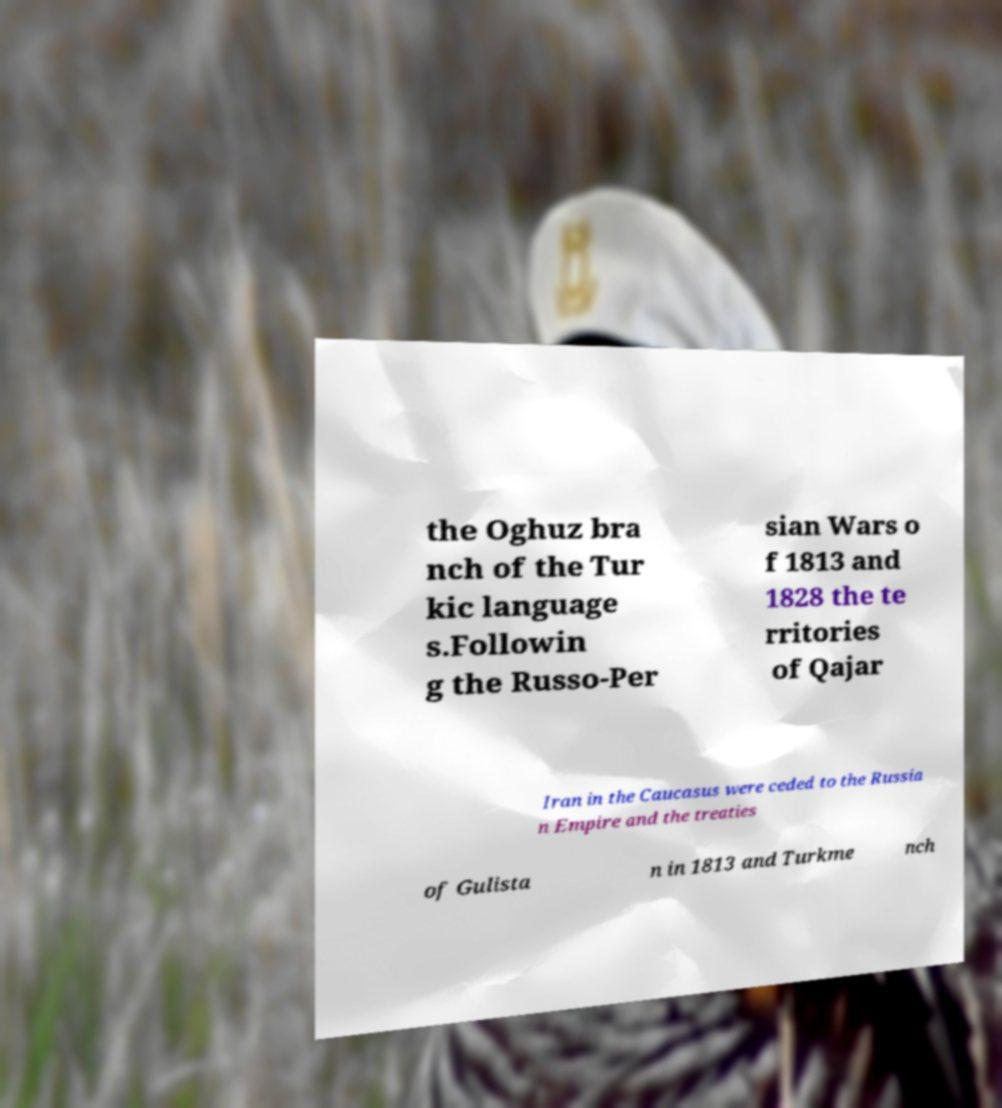Could you extract and type out the text from this image? the Oghuz bra nch of the Tur kic language s.Followin g the Russo-Per sian Wars o f 1813 and 1828 the te rritories of Qajar Iran in the Caucasus were ceded to the Russia n Empire and the treaties of Gulista n in 1813 and Turkme nch 